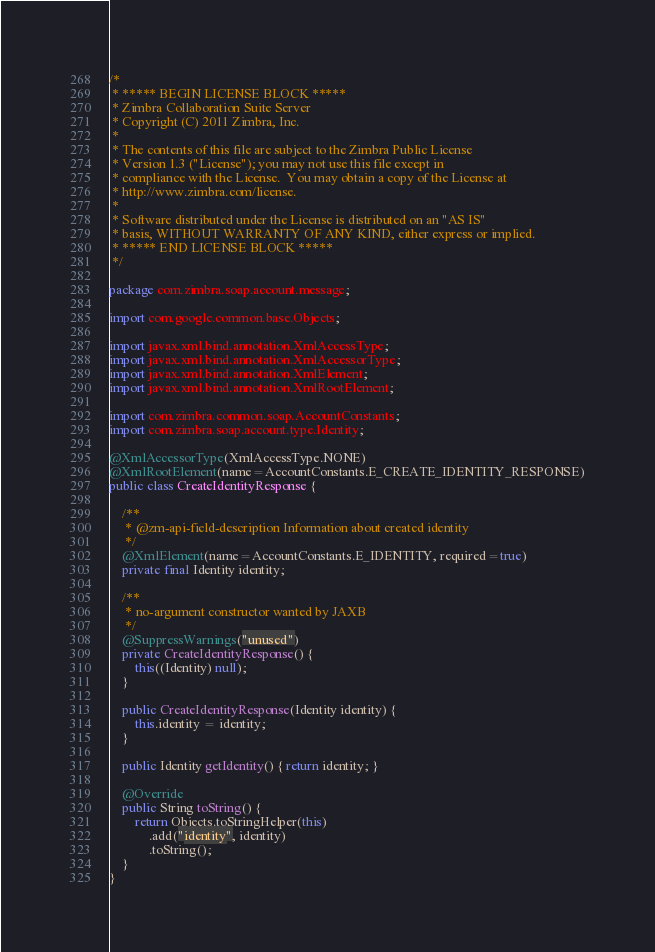<code> <loc_0><loc_0><loc_500><loc_500><_Java_>/*
 * ***** BEGIN LICENSE BLOCK *****
 * Zimbra Collaboration Suite Server
 * Copyright (C) 2011 Zimbra, Inc.
 *
 * The contents of this file are subject to the Zimbra Public License
 * Version 1.3 ("License"); you may not use this file except in
 * compliance with the License.  You may obtain a copy of the License at
 * http://www.zimbra.com/license.
 *
 * Software distributed under the License is distributed on an "AS IS"
 * basis, WITHOUT WARRANTY OF ANY KIND, either express or implied.
 * ***** END LICENSE BLOCK *****
 */

package com.zimbra.soap.account.message;

import com.google.common.base.Objects;

import javax.xml.bind.annotation.XmlAccessType;
import javax.xml.bind.annotation.XmlAccessorType;
import javax.xml.bind.annotation.XmlElement;
import javax.xml.bind.annotation.XmlRootElement;

import com.zimbra.common.soap.AccountConstants;
import com.zimbra.soap.account.type.Identity;

@XmlAccessorType(XmlAccessType.NONE)
@XmlRootElement(name=AccountConstants.E_CREATE_IDENTITY_RESPONSE)
public class CreateIdentityResponse {

    /**
     * @zm-api-field-description Information about created identity
     */
    @XmlElement(name=AccountConstants.E_IDENTITY, required=true)
    private final Identity identity;

    /**
     * no-argument constructor wanted by JAXB
     */
    @SuppressWarnings("unused")
    private CreateIdentityResponse() {
        this((Identity) null);
    }

    public CreateIdentityResponse(Identity identity) {
        this.identity = identity;
    }

    public Identity getIdentity() { return identity; }

    @Override
    public String toString() {
        return Objects.toStringHelper(this)
            .add("identity", identity)
            .toString();
    }
}
</code> 